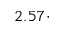Convert formula to latex. <formula><loc_0><loc_0><loc_500><loc_500>2 . 5 7 \cdot</formula> 